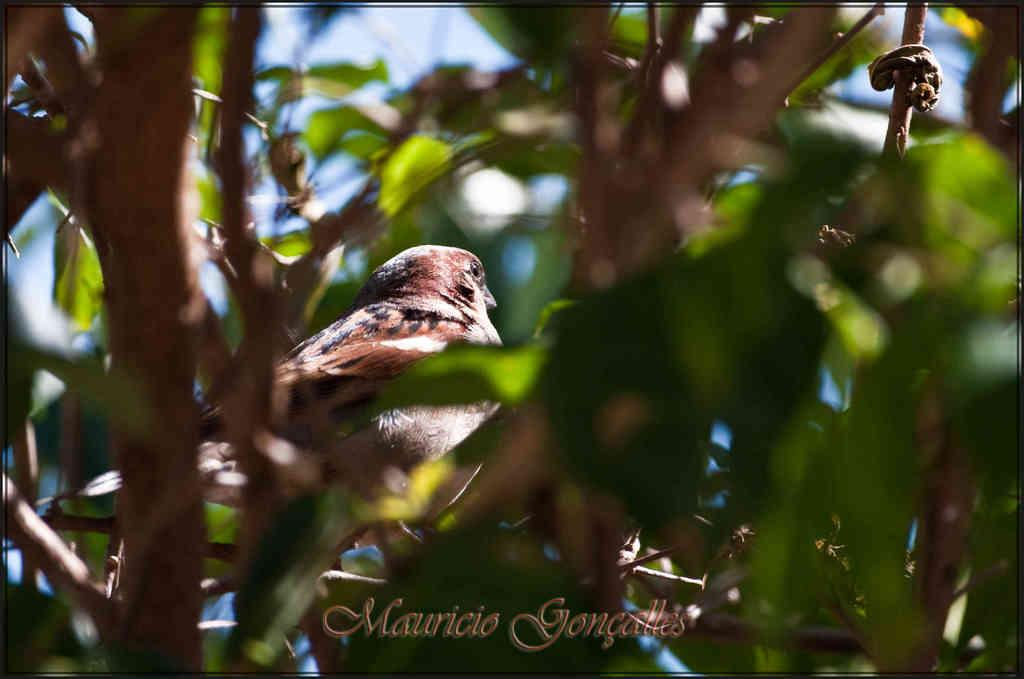What type of animal can be seen in the image? There is a bird in the image. What is the bird perched on in the image? There is a tree in the image. What can be seen in the background of the image? The sky is visible in the image. Is there any text present in the image? Yes, there is written text at the bottom of the image. What type of corn is being harvested by the bird in the image? There is no corn present in the image, and the bird is not harvesting anything. 